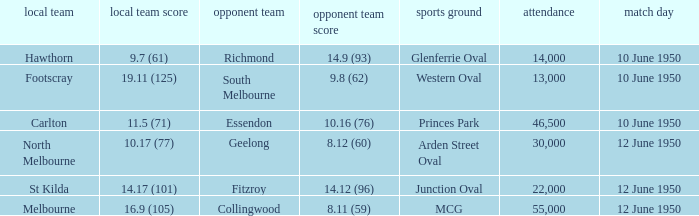What was the crowd when Melbourne was the home team? 55000.0. 